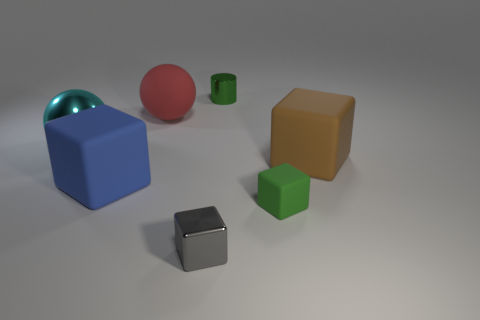Add 1 gray metal objects. How many objects exist? 8 Subtract all big blue matte blocks. How many blocks are left? 3 Subtract all brown blocks. How many blocks are left? 3 Subtract all cylinders. How many objects are left? 6 Subtract 1 cylinders. How many cylinders are left? 0 Subtract all large brown rubber spheres. Subtract all blue cubes. How many objects are left? 6 Add 2 large rubber things. How many large rubber things are left? 5 Add 5 small blocks. How many small blocks exist? 7 Subtract 1 green cylinders. How many objects are left? 6 Subtract all brown spheres. Subtract all yellow cylinders. How many spheres are left? 2 